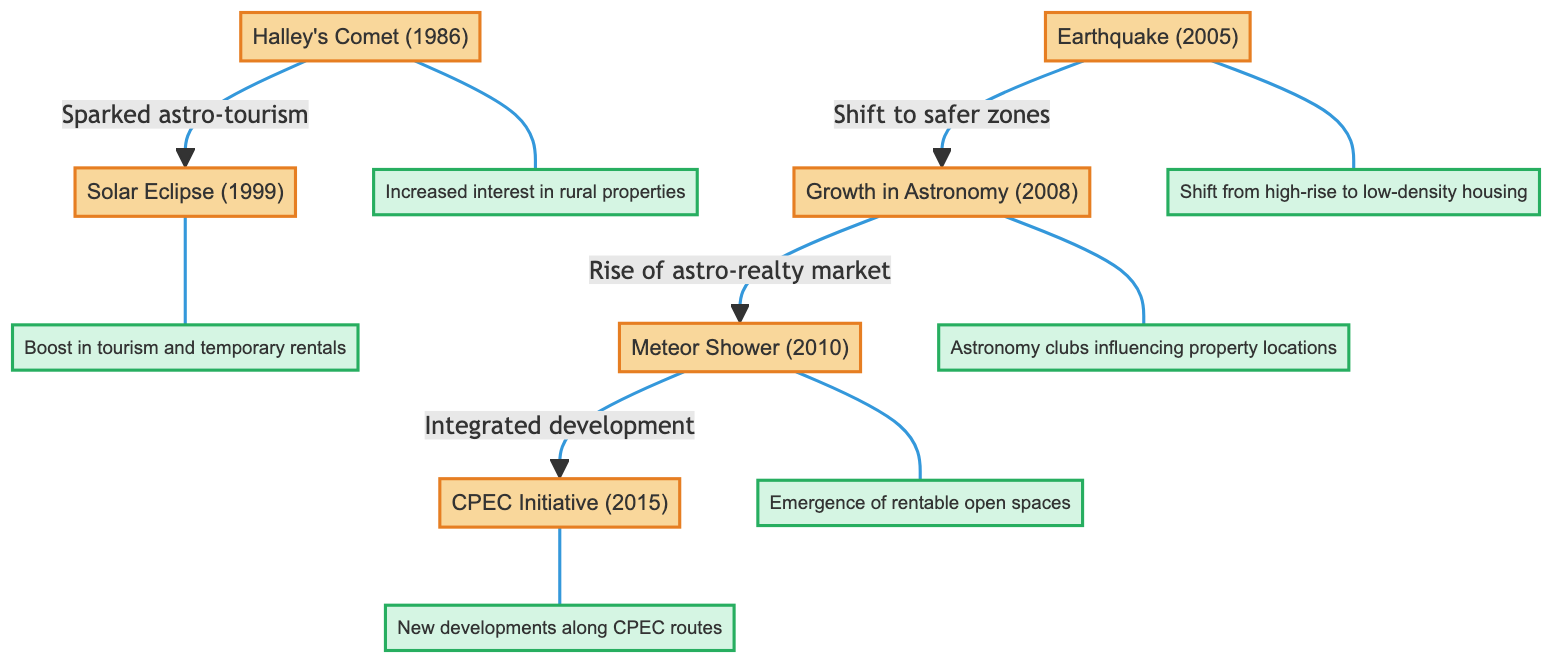What event sparked astro-tourism in Pakistan? The diagram shows that Halley's Comet in 1986 led to the spark of astro-tourism in Pakistan, as indicated by the arrow connecting HC1986 to SE1999.
Answer: Halley's Comet (1986) What is the impact of the Solar Eclipse in 1999? The diagram illustrates that the Solar Eclipse in 1999 resulted in a boost in tourism and temporary rentals, indicated by the arrow from SE1999 to SE1999_impact.
Answer: Boost in tourism and temporary rentals How many major astronomical events are listed in the diagram? By counting the distinct events outlined in the diagram, we find Halley's Comet, the Solar Eclipse, the Earthquake, the growth in Astronomy, the Meteor Shower, and the CPEC Initiative, totaling six events.
Answer: 6 What change in housing preference occurred after the Earthquake in 2005? The diagram indicates that the Earthquake in 2005 led to a shift from high-rise to low-density housing, as shown by the relationship from EQ2005 to EQ2005_impact.
Answer: Shift from high-rise to low-density housing What did the growth in Astronomy in 2008 influence in real estate? The diagram reveals that the growth in Astronomy in 2008 influenced the rise of the astro-realty market, connecting AI2008 to MS2010 through the development indicated.
Answer: Rise of astro-realty market Which event led to new developments along the CPEC routes? The diagram connects the CPEC Initiative in 2015 to the impact of new developments along CPEC routes, indicating a direct relationship.
Answer: CPEC Initiative (2015) What is the relationship between the Meteor Shower in 2010 and real estate? The diagram shows that the Meteor Shower in 2010 resulted in the emergence of rentable open spaces, establishing a connection between MS2010 and its impact.
Answer: Emergence of rentable open spaces What effect did Halley's Comet (1986) have on property interest? The impact of Halley's Comet is linked in the diagram, showing the result as increased interest in rural properties, based on the connection to HC1986_impact.
Answer: Increased interest in rural properties 